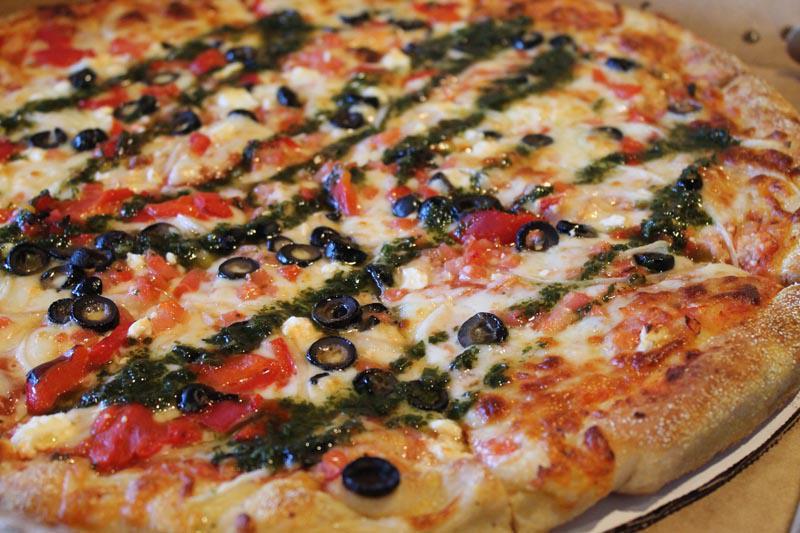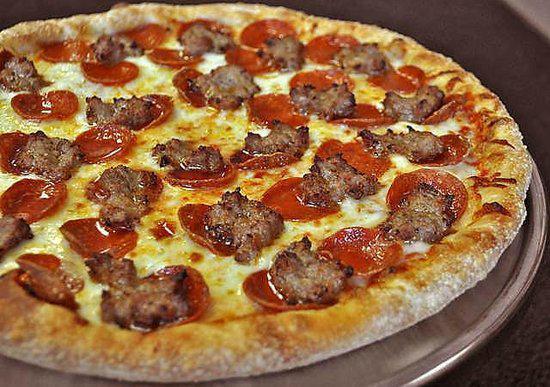The first image is the image on the left, the second image is the image on the right. Examine the images to the left and right. Is the description "The left pizza has something green on it." accurate? Answer yes or no. Yes. The first image is the image on the left, the second image is the image on the right. Given the left and right images, does the statement "There are two pizza that are perfect circles." hold true? Answer yes or no. Yes. 